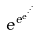<formula> <loc_0><loc_0><loc_500><loc_500>e ^ { e ^ { e ^ { \cdot ^ { \cdot ^ { \cdot } } } } }</formula> 